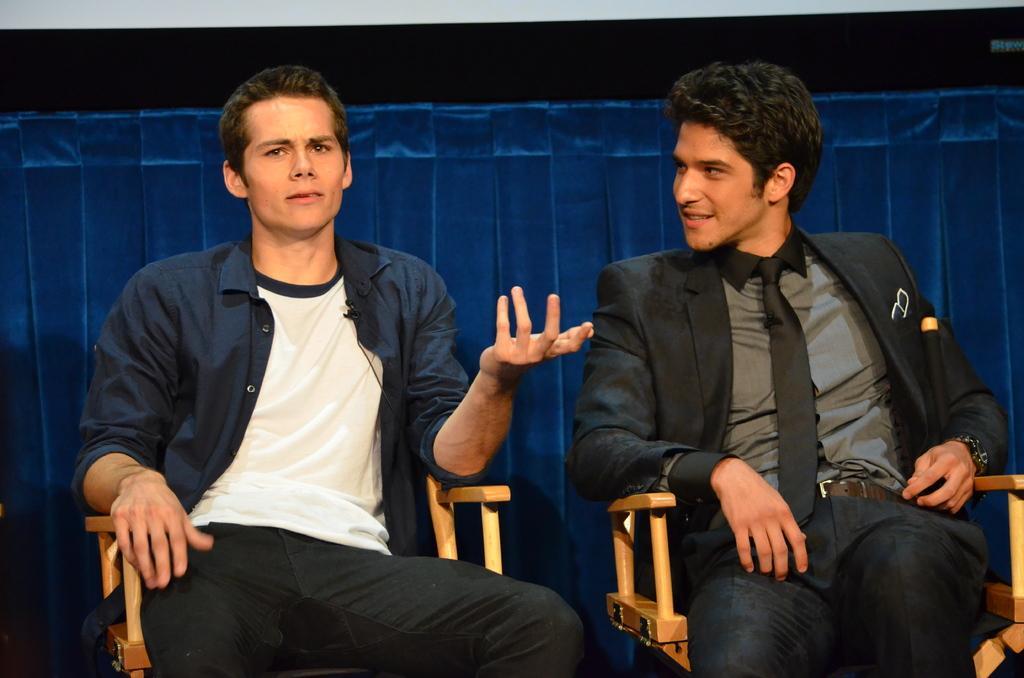Can you describe this image briefly? In this image I see 2 men who are sitting on chairs and this man is wearing a suit and this man is wearing blue color shirt and I see the blue color things in the background. 